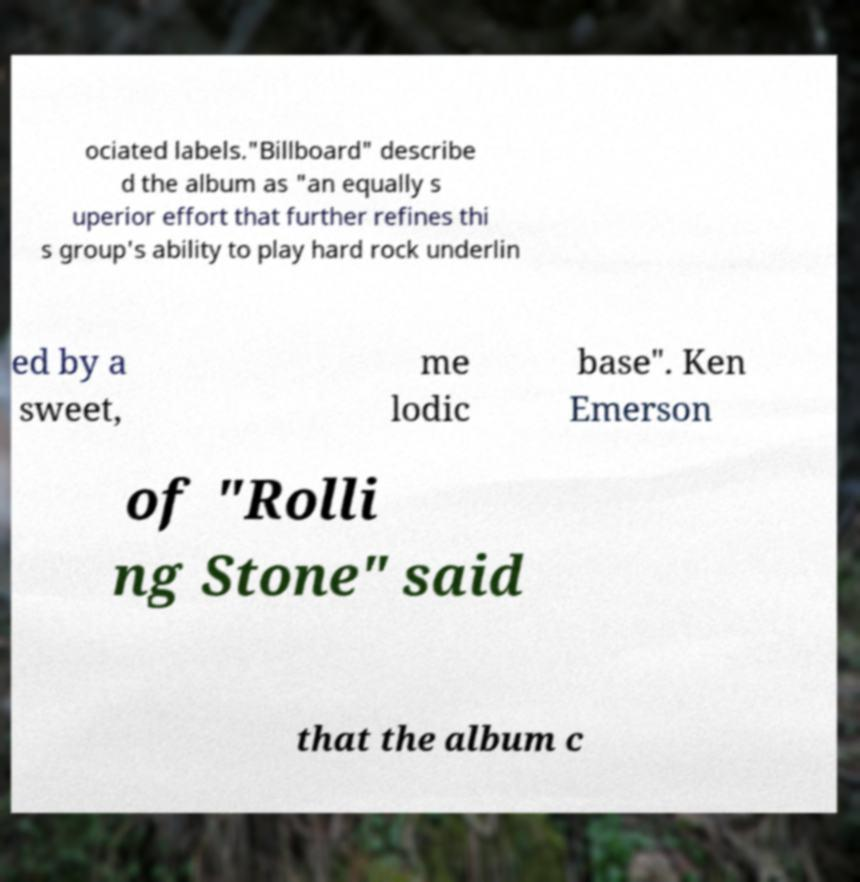What messages or text are displayed in this image? I need them in a readable, typed format. ociated labels."Billboard" describe d the album as "an equally s uperior effort that further refines thi s group's ability to play hard rock underlin ed by a sweet, me lodic base". Ken Emerson of "Rolli ng Stone" said that the album c 